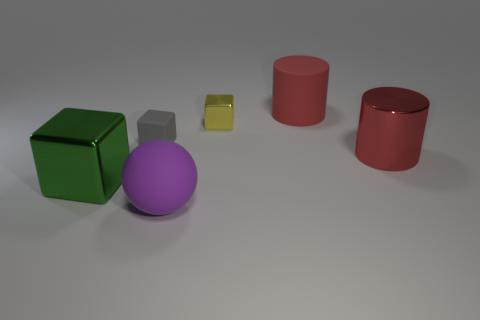Add 2 big red rubber objects. How many objects exist? 8 Subtract all cylinders. How many objects are left? 4 Add 4 yellow metal objects. How many yellow metal objects are left? 5 Add 3 purple matte spheres. How many purple matte spheres exist? 4 Subtract 0 blue cylinders. How many objects are left? 6 Subtract all purple rubber balls. Subtract all purple matte balls. How many objects are left? 4 